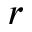Convert formula to latex. <formula><loc_0><loc_0><loc_500><loc_500>r</formula> 